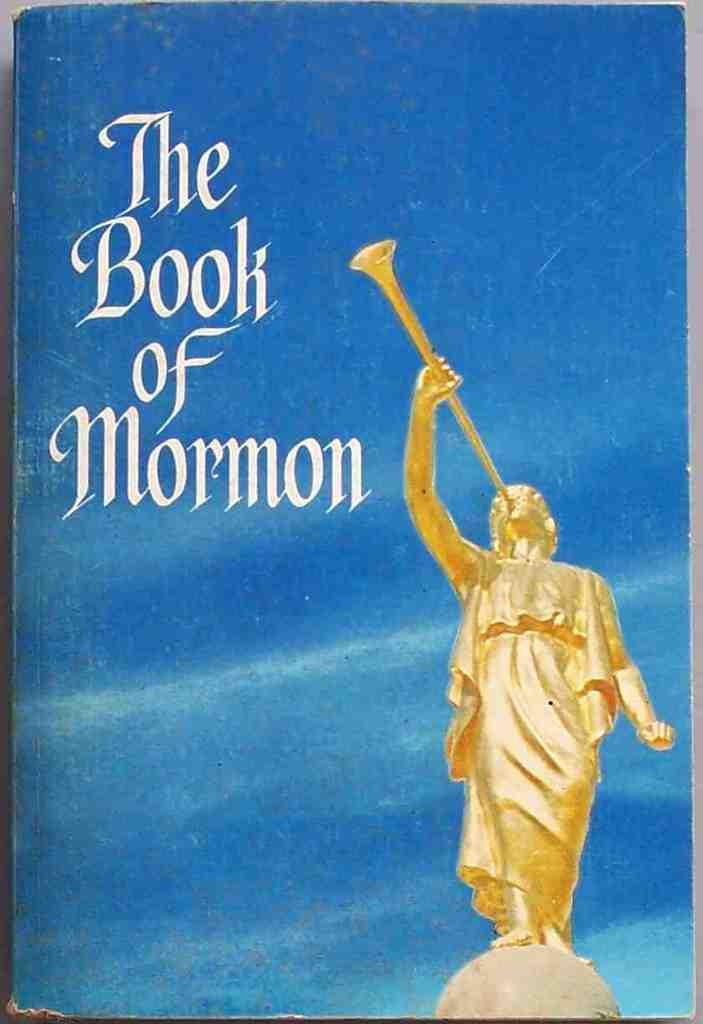<image>
Render a clear and concise summary of the photo. A book called the book of Mormon with a gold person blowing a trumpet. 